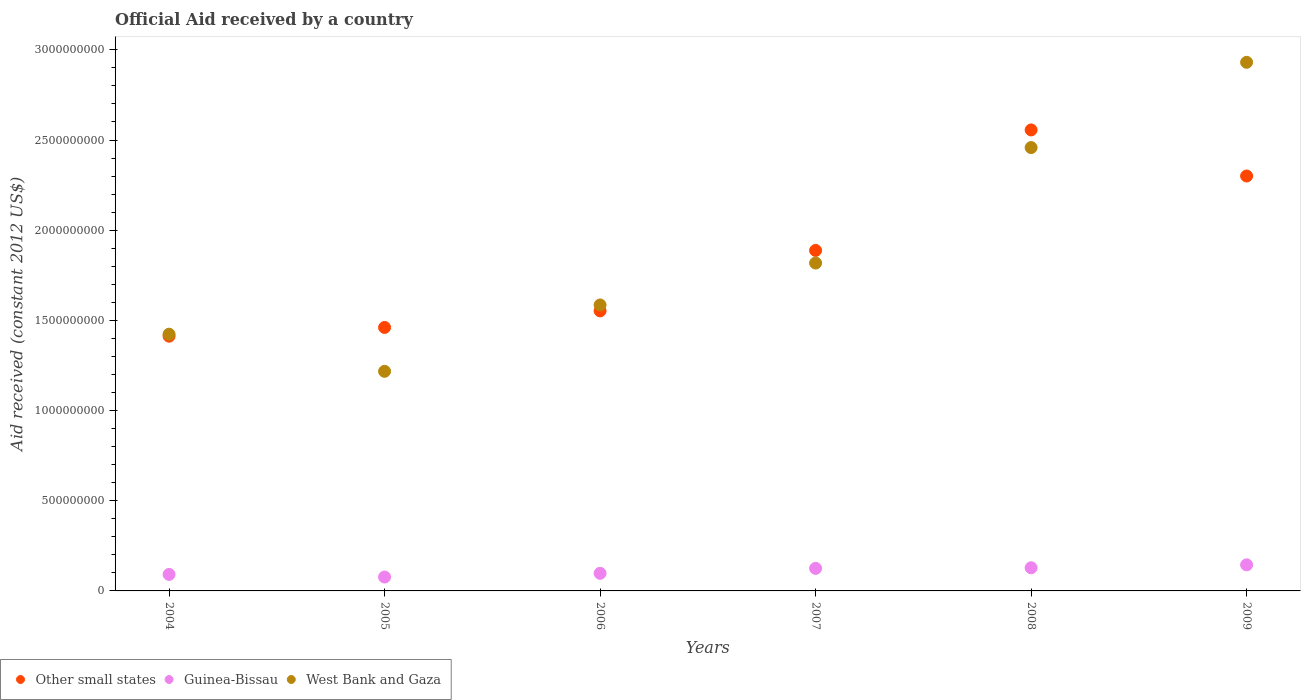How many different coloured dotlines are there?
Your answer should be very brief. 3. Is the number of dotlines equal to the number of legend labels?
Your answer should be very brief. Yes. What is the net official aid received in Guinea-Bissau in 2005?
Your answer should be compact. 7.70e+07. Across all years, what is the maximum net official aid received in West Bank and Gaza?
Your answer should be very brief. 2.93e+09. Across all years, what is the minimum net official aid received in Guinea-Bissau?
Offer a very short reply. 7.70e+07. What is the total net official aid received in Guinea-Bissau in the graph?
Make the answer very short. 6.64e+08. What is the difference between the net official aid received in Guinea-Bissau in 2004 and that in 2006?
Offer a terse response. -6.04e+06. What is the difference between the net official aid received in Other small states in 2009 and the net official aid received in West Bank and Gaza in 2008?
Your answer should be compact. -1.58e+08. What is the average net official aid received in Guinea-Bissau per year?
Provide a succinct answer. 1.11e+08. In the year 2007, what is the difference between the net official aid received in West Bank and Gaza and net official aid received in Guinea-Bissau?
Offer a very short reply. 1.69e+09. What is the ratio of the net official aid received in Other small states in 2004 to that in 2005?
Make the answer very short. 0.97. Is the difference between the net official aid received in West Bank and Gaza in 2004 and 2008 greater than the difference between the net official aid received in Guinea-Bissau in 2004 and 2008?
Make the answer very short. No. What is the difference between the highest and the second highest net official aid received in Guinea-Bissau?
Give a very brief answer. 1.62e+07. What is the difference between the highest and the lowest net official aid received in West Bank and Gaza?
Your answer should be very brief. 1.71e+09. In how many years, is the net official aid received in Guinea-Bissau greater than the average net official aid received in Guinea-Bissau taken over all years?
Your response must be concise. 3. Is it the case that in every year, the sum of the net official aid received in Other small states and net official aid received in West Bank and Gaza  is greater than the net official aid received in Guinea-Bissau?
Offer a very short reply. Yes. Is the net official aid received in Guinea-Bissau strictly less than the net official aid received in West Bank and Gaza over the years?
Ensure brevity in your answer.  Yes. How many years are there in the graph?
Offer a very short reply. 6. Does the graph contain grids?
Your answer should be very brief. No. How are the legend labels stacked?
Make the answer very short. Horizontal. What is the title of the graph?
Your response must be concise. Official Aid received by a country. What is the label or title of the X-axis?
Keep it short and to the point. Years. What is the label or title of the Y-axis?
Offer a terse response. Aid received (constant 2012 US$). What is the Aid received (constant 2012 US$) of Other small states in 2004?
Keep it short and to the point. 1.41e+09. What is the Aid received (constant 2012 US$) of Guinea-Bissau in 2004?
Keep it short and to the point. 9.15e+07. What is the Aid received (constant 2012 US$) of West Bank and Gaza in 2004?
Keep it short and to the point. 1.42e+09. What is the Aid received (constant 2012 US$) in Other small states in 2005?
Give a very brief answer. 1.46e+09. What is the Aid received (constant 2012 US$) in Guinea-Bissau in 2005?
Offer a very short reply. 7.70e+07. What is the Aid received (constant 2012 US$) in West Bank and Gaza in 2005?
Offer a terse response. 1.22e+09. What is the Aid received (constant 2012 US$) of Other small states in 2006?
Provide a succinct answer. 1.55e+09. What is the Aid received (constant 2012 US$) in Guinea-Bissau in 2006?
Offer a very short reply. 9.75e+07. What is the Aid received (constant 2012 US$) of West Bank and Gaza in 2006?
Make the answer very short. 1.59e+09. What is the Aid received (constant 2012 US$) of Other small states in 2007?
Ensure brevity in your answer.  1.89e+09. What is the Aid received (constant 2012 US$) in Guinea-Bissau in 2007?
Offer a very short reply. 1.25e+08. What is the Aid received (constant 2012 US$) in West Bank and Gaza in 2007?
Your answer should be very brief. 1.82e+09. What is the Aid received (constant 2012 US$) in Other small states in 2008?
Give a very brief answer. 2.56e+09. What is the Aid received (constant 2012 US$) of Guinea-Bissau in 2008?
Make the answer very short. 1.28e+08. What is the Aid received (constant 2012 US$) of West Bank and Gaza in 2008?
Your response must be concise. 2.46e+09. What is the Aid received (constant 2012 US$) of Other small states in 2009?
Your answer should be very brief. 2.30e+09. What is the Aid received (constant 2012 US$) of Guinea-Bissau in 2009?
Your answer should be compact. 1.45e+08. What is the Aid received (constant 2012 US$) of West Bank and Gaza in 2009?
Your answer should be compact. 2.93e+09. Across all years, what is the maximum Aid received (constant 2012 US$) of Other small states?
Your answer should be very brief. 2.56e+09. Across all years, what is the maximum Aid received (constant 2012 US$) of Guinea-Bissau?
Provide a succinct answer. 1.45e+08. Across all years, what is the maximum Aid received (constant 2012 US$) of West Bank and Gaza?
Your response must be concise. 2.93e+09. Across all years, what is the minimum Aid received (constant 2012 US$) of Other small states?
Offer a very short reply. 1.41e+09. Across all years, what is the minimum Aid received (constant 2012 US$) in Guinea-Bissau?
Your answer should be very brief. 7.70e+07. Across all years, what is the minimum Aid received (constant 2012 US$) in West Bank and Gaza?
Your response must be concise. 1.22e+09. What is the total Aid received (constant 2012 US$) of Other small states in the graph?
Provide a succinct answer. 1.12e+1. What is the total Aid received (constant 2012 US$) of Guinea-Bissau in the graph?
Your answer should be compact. 6.64e+08. What is the total Aid received (constant 2012 US$) in West Bank and Gaza in the graph?
Your answer should be compact. 1.14e+1. What is the difference between the Aid received (constant 2012 US$) in Other small states in 2004 and that in 2005?
Provide a short and direct response. -4.84e+07. What is the difference between the Aid received (constant 2012 US$) of Guinea-Bissau in 2004 and that in 2005?
Make the answer very short. 1.45e+07. What is the difference between the Aid received (constant 2012 US$) in West Bank and Gaza in 2004 and that in 2005?
Provide a short and direct response. 2.06e+08. What is the difference between the Aid received (constant 2012 US$) in Other small states in 2004 and that in 2006?
Make the answer very short. -1.40e+08. What is the difference between the Aid received (constant 2012 US$) of Guinea-Bissau in 2004 and that in 2006?
Ensure brevity in your answer.  -6.04e+06. What is the difference between the Aid received (constant 2012 US$) in West Bank and Gaza in 2004 and that in 2006?
Offer a very short reply. -1.62e+08. What is the difference between the Aid received (constant 2012 US$) in Other small states in 2004 and that in 2007?
Offer a very short reply. -4.75e+08. What is the difference between the Aid received (constant 2012 US$) in Guinea-Bissau in 2004 and that in 2007?
Provide a short and direct response. -3.35e+07. What is the difference between the Aid received (constant 2012 US$) in West Bank and Gaza in 2004 and that in 2007?
Keep it short and to the point. -3.94e+08. What is the difference between the Aid received (constant 2012 US$) in Other small states in 2004 and that in 2008?
Make the answer very short. -1.14e+09. What is the difference between the Aid received (constant 2012 US$) in Guinea-Bissau in 2004 and that in 2008?
Ensure brevity in your answer.  -3.69e+07. What is the difference between the Aid received (constant 2012 US$) in West Bank and Gaza in 2004 and that in 2008?
Make the answer very short. -1.03e+09. What is the difference between the Aid received (constant 2012 US$) in Other small states in 2004 and that in 2009?
Keep it short and to the point. -8.88e+08. What is the difference between the Aid received (constant 2012 US$) in Guinea-Bissau in 2004 and that in 2009?
Provide a succinct answer. -5.32e+07. What is the difference between the Aid received (constant 2012 US$) of West Bank and Gaza in 2004 and that in 2009?
Keep it short and to the point. -1.51e+09. What is the difference between the Aid received (constant 2012 US$) in Other small states in 2005 and that in 2006?
Your answer should be compact. -9.18e+07. What is the difference between the Aid received (constant 2012 US$) in Guinea-Bissau in 2005 and that in 2006?
Your answer should be very brief. -2.05e+07. What is the difference between the Aid received (constant 2012 US$) of West Bank and Gaza in 2005 and that in 2006?
Provide a short and direct response. -3.68e+08. What is the difference between the Aid received (constant 2012 US$) of Other small states in 2005 and that in 2007?
Offer a terse response. -4.27e+08. What is the difference between the Aid received (constant 2012 US$) of Guinea-Bissau in 2005 and that in 2007?
Your answer should be compact. -4.80e+07. What is the difference between the Aid received (constant 2012 US$) of West Bank and Gaza in 2005 and that in 2007?
Give a very brief answer. -6.00e+08. What is the difference between the Aid received (constant 2012 US$) in Other small states in 2005 and that in 2008?
Your answer should be compact. -1.10e+09. What is the difference between the Aid received (constant 2012 US$) of Guinea-Bissau in 2005 and that in 2008?
Ensure brevity in your answer.  -5.14e+07. What is the difference between the Aid received (constant 2012 US$) in West Bank and Gaza in 2005 and that in 2008?
Make the answer very short. -1.24e+09. What is the difference between the Aid received (constant 2012 US$) in Other small states in 2005 and that in 2009?
Your answer should be very brief. -8.40e+08. What is the difference between the Aid received (constant 2012 US$) in Guinea-Bissau in 2005 and that in 2009?
Your answer should be compact. -6.76e+07. What is the difference between the Aid received (constant 2012 US$) in West Bank and Gaza in 2005 and that in 2009?
Your response must be concise. -1.71e+09. What is the difference between the Aid received (constant 2012 US$) in Other small states in 2006 and that in 2007?
Your answer should be compact. -3.35e+08. What is the difference between the Aid received (constant 2012 US$) of Guinea-Bissau in 2006 and that in 2007?
Provide a short and direct response. -2.75e+07. What is the difference between the Aid received (constant 2012 US$) of West Bank and Gaza in 2006 and that in 2007?
Provide a succinct answer. -2.32e+08. What is the difference between the Aid received (constant 2012 US$) in Other small states in 2006 and that in 2008?
Ensure brevity in your answer.  -1.00e+09. What is the difference between the Aid received (constant 2012 US$) in Guinea-Bissau in 2006 and that in 2008?
Your response must be concise. -3.09e+07. What is the difference between the Aid received (constant 2012 US$) in West Bank and Gaza in 2006 and that in 2008?
Give a very brief answer. -8.73e+08. What is the difference between the Aid received (constant 2012 US$) in Other small states in 2006 and that in 2009?
Your answer should be very brief. -7.48e+08. What is the difference between the Aid received (constant 2012 US$) in Guinea-Bissau in 2006 and that in 2009?
Provide a succinct answer. -4.71e+07. What is the difference between the Aid received (constant 2012 US$) in West Bank and Gaza in 2006 and that in 2009?
Offer a very short reply. -1.35e+09. What is the difference between the Aid received (constant 2012 US$) in Other small states in 2007 and that in 2008?
Your response must be concise. -6.68e+08. What is the difference between the Aid received (constant 2012 US$) of Guinea-Bissau in 2007 and that in 2008?
Give a very brief answer. -3.38e+06. What is the difference between the Aid received (constant 2012 US$) in West Bank and Gaza in 2007 and that in 2008?
Your response must be concise. -6.40e+08. What is the difference between the Aid received (constant 2012 US$) of Other small states in 2007 and that in 2009?
Make the answer very short. -4.13e+08. What is the difference between the Aid received (constant 2012 US$) of Guinea-Bissau in 2007 and that in 2009?
Your response must be concise. -1.96e+07. What is the difference between the Aid received (constant 2012 US$) of West Bank and Gaza in 2007 and that in 2009?
Keep it short and to the point. -1.11e+09. What is the difference between the Aid received (constant 2012 US$) of Other small states in 2008 and that in 2009?
Provide a short and direct response. 2.55e+08. What is the difference between the Aid received (constant 2012 US$) in Guinea-Bissau in 2008 and that in 2009?
Ensure brevity in your answer.  -1.62e+07. What is the difference between the Aid received (constant 2012 US$) of West Bank and Gaza in 2008 and that in 2009?
Provide a short and direct response. -4.73e+08. What is the difference between the Aid received (constant 2012 US$) in Other small states in 2004 and the Aid received (constant 2012 US$) in Guinea-Bissau in 2005?
Keep it short and to the point. 1.34e+09. What is the difference between the Aid received (constant 2012 US$) in Other small states in 2004 and the Aid received (constant 2012 US$) in West Bank and Gaza in 2005?
Offer a very short reply. 1.95e+08. What is the difference between the Aid received (constant 2012 US$) in Guinea-Bissau in 2004 and the Aid received (constant 2012 US$) in West Bank and Gaza in 2005?
Your response must be concise. -1.13e+09. What is the difference between the Aid received (constant 2012 US$) of Other small states in 2004 and the Aid received (constant 2012 US$) of Guinea-Bissau in 2006?
Offer a very short reply. 1.31e+09. What is the difference between the Aid received (constant 2012 US$) of Other small states in 2004 and the Aid received (constant 2012 US$) of West Bank and Gaza in 2006?
Your response must be concise. -1.73e+08. What is the difference between the Aid received (constant 2012 US$) of Guinea-Bissau in 2004 and the Aid received (constant 2012 US$) of West Bank and Gaza in 2006?
Offer a very short reply. -1.49e+09. What is the difference between the Aid received (constant 2012 US$) of Other small states in 2004 and the Aid received (constant 2012 US$) of Guinea-Bissau in 2007?
Give a very brief answer. 1.29e+09. What is the difference between the Aid received (constant 2012 US$) in Other small states in 2004 and the Aid received (constant 2012 US$) in West Bank and Gaza in 2007?
Your response must be concise. -4.06e+08. What is the difference between the Aid received (constant 2012 US$) in Guinea-Bissau in 2004 and the Aid received (constant 2012 US$) in West Bank and Gaza in 2007?
Give a very brief answer. -1.73e+09. What is the difference between the Aid received (constant 2012 US$) of Other small states in 2004 and the Aid received (constant 2012 US$) of Guinea-Bissau in 2008?
Keep it short and to the point. 1.28e+09. What is the difference between the Aid received (constant 2012 US$) of Other small states in 2004 and the Aid received (constant 2012 US$) of West Bank and Gaza in 2008?
Offer a very short reply. -1.05e+09. What is the difference between the Aid received (constant 2012 US$) in Guinea-Bissau in 2004 and the Aid received (constant 2012 US$) in West Bank and Gaza in 2008?
Offer a very short reply. -2.37e+09. What is the difference between the Aid received (constant 2012 US$) in Other small states in 2004 and the Aid received (constant 2012 US$) in Guinea-Bissau in 2009?
Your answer should be compact. 1.27e+09. What is the difference between the Aid received (constant 2012 US$) in Other small states in 2004 and the Aid received (constant 2012 US$) in West Bank and Gaza in 2009?
Your answer should be compact. -1.52e+09. What is the difference between the Aid received (constant 2012 US$) of Guinea-Bissau in 2004 and the Aid received (constant 2012 US$) of West Bank and Gaza in 2009?
Your answer should be very brief. -2.84e+09. What is the difference between the Aid received (constant 2012 US$) in Other small states in 2005 and the Aid received (constant 2012 US$) in Guinea-Bissau in 2006?
Keep it short and to the point. 1.36e+09. What is the difference between the Aid received (constant 2012 US$) in Other small states in 2005 and the Aid received (constant 2012 US$) in West Bank and Gaza in 2006?
Your answer should be compact. -1.25e+08. What is the difference between the Aid received (constant 2012 US$) of Guinea-Bissau in 2005 and the Aid received (constant 2012 US$) of West Bank and Gaza in 2006?
Keep it short and to the point. -1.51e+09. What is the difference between the Aid received (constant 2012 US$) in Other small states in 2005 and the Aid received (constant 2012 US$) in Guinea-Bissau in 2007?
Give a very brief answer. 1.34e+09. What is the difference between the Aid received (constant 2012 US$) in Other small states in 2005 and the Aid received (constant 2012 US$) in West Bank and Gaza in 2007?
Give a very brief answer. -3.57e+08. What is the difference between the Aid received (constant 2012 US$) of Guinea-Bissau in 2005 and the Aid received (constant 2012 US$) of West Bank and Gaza in 2007?
Offer a terse response. -1.74e+09. What is the difference between the Aid received (constant 2012 US$) of Other small states in 2005 and the Aid received (constant 2012 US$) of Guinea-Bissau in 2008?
Your response must be concise. 1.33e+09. What is the difference between the Aid received (constant 2012 US$) in Other small states in 2005 and the Aid received (constant 2012 US$) in West Bank and Gaza in 2008?
Make the answer very short. -9.97e+08. What is the difference between the Aid received (constant 2012 US$) in Guinea-Bissau in 2005 and the Aid received (constant 2012 US$) in West Bank and Gaza in 2008?
Give a very brief answer. -2.38e+09. What is the difference between the Aid received (constant 2012 US$) of Other small states in 2005 and the Aid received (constant 2012 US$) of Guinea-Bissau in 2009?
Keep it short and to the point. 1.32e+09. What is the difference between the Aid received (constant 2012 US$) in Other small states in 2005 and the Aid received (constant 2012 US$) in West Bank and Gaza in 2009?
Offer a very short reply. -1.47e+09. What is the difference between the Aid received (constant 2012 US$) of Guinea-Bissau in 2005 and the Aid received (constant 2012 US$) of West Bank and Gaza in 2009?
Your answer should be very brief. -2.85e+09. What is the difference between the Aid received (constant 2012 US$) of Other small states in 2006 and the Aid received (constant 2012 US$) of Guinea-Bissau in 2007?
Your answer should be very brief. 1.43e+09. What is the difference between the Aid received (constant 2012 US$) of Other small states in 2006 and the Aid received (constant 2012 US$) of West Bank and Gaza in 2007?
Your response must be concise. -2.65e+08. What is the difference between the Aid received (constant 2012 US$) in Guinea-Bissau in 2006 and the Aid received (constant 2012 US$) in West Bank and Gaza in 2007?
Ensure brevity in your answer.  -1.72e+09. What is the difference between the Aid received (constant 2012 US$) in Other small states in 2006 and the Aid received (constant 2012 US$) in Guinea-Bissau in 2008?
Your answer should be compact. 1.42e+09. What is the difference between the Aid received (constant 2012 US$) of Other small states in 2006 and the Aid received (constant 2012 US$) of West Bank and Gaza in 2008?
Your response must be concise. -9.06e+08. What is the difference between the Aid received (constant 2012 US$) in Guinea-Bissau in 2006 and the Aid received (constant 2012 US$) in West Bank and Gaza in 2008?
Give a very brief answer. -2.36e+09. What is the difference between the Aid received (constant 2012 US$) in Other small states in 2006 and the Aid received (constant 2012 US$) in Guinea-Bissau in 2009?
Provide a succinct answer. 1.41e+09. What is the difference between the Aid received (constant 2012 US$) of Other small states in 2006 and the Aid received (constant 2012 US$) of West Bank and Gaza in 2009?
Make the answer very short. -1.38e+09. What is the difference between the Aid received (constant 2012 US$) in Guinea-Bissau in 2006 and the Aid received (constant 2012 US$) in West Bank and Gaza in 2009?
Your answer should be compact. -2.83e+09. What is the difference between the Aid received (constant 2012 US$) in Other small states in 2007 and the Aid received (constant 2012 US$) in Guinea-Bissau in 2008?
Your response must be concise. 1.76e+09. What is the difference between the Aid received (constant 2012 US$) of Other small states in 2007 and the Aid received (constant 2012 US$) of West Bank and Gaza in 2008?
Keep it short and to the point. -5.70e+08. What is the difference between the Aid received (constant 2012 US$) of Guinea-Bissau in 2007 and the Aid received (constant 2012 US$) of West Bank and Gaza in 2008?
Offer a terse response. -2.33e+09. What is the difference between the Aid received (constant 2012 US$) of Other small states in 2007 and the Aid received (constant 2012 US$) of Guinea-Bissau in 2009?
Offer a very short reply. 1.74e+09. What is the difference between the Aid received (constant 2012 US$) in Other small states in 2007 and the Aid received (constant 2012 US$) in West Bank and Gaza in 2009?
Provide a succinct answer. -1.04e+09. What is the difference between the Aid received (constant 2012 US$) of Guinea-Bissau in 2007 and the Aid received (constant 2012 US$) of West Bank and Gaza in 2009?
Make the answer very short. -2.81e+09. What is the difference between the Aid received (constant 2012 US$) in Other small states in 2008 and the Aid received (constant 2012 US$) in Guinea-Bissau in 2009?
Your answer should be very brief. 2.41e+09. What is the difference between the Aid received (constant 2012 US$) in Other small states in 2008 and the Aid received (constant 2012 US$) in West Bank and Gaza in 2009?
Your answer should be very brief. -3.75e+08. What is the difference between the Aid received (constant 2012 US$) of Guinea-Bissau in 2008 and the Aid received (constant 2012 US$) of West Bank and Gaza in 2009?
Your answer should be compact. -2.80e+09. What is the average Aid received (constant 2012 US$) of Other small states per year?
Your answer should be compact. 1.86e+09. What is the average Aid received (constant 2012 US$) in Guinea-Bissau per year?
Make the answer very short. 1.11e+08. What is the average Aid received (constant 2012 US$) of West Bank and Gaza per year?
Offer a terse response. 1.91e+09. In the year 2004, what is the difference between the Aid received (constant 2012 US$) of Other small states and Aid received (constant 2012 US$) of Guinea-Bissau?
Offer a terse response. 1.32e+09. In the year 2004, what is the difference between the Aid received (constant 2012 US$) of Other small states and Aid received (constant 2012 US$) of West Bank and Gaza?
Your response must be concise. -1.11e+07. In the year 2004, what is the difference between the Aid received (constant 2012 US$) of Guinea-Bissau and Aid received (constant 2012 US$) of West Bank and Gaza?
Make the answer very short. -1.33e+09. In the year 2005, what is the difference between the Aid received (constant 2012 US$) in Other small states and Aid received (constant 2012 US$) in Guinea-Bissau?
Ensure brevity in your answer.  1.38e+09. In the year 2005, what is the difference between the Aid received (constant 2012 US$) in Other small states and Aid received (constant 2012 US$) in West Bank and Gaza?
Make the answer very short. 2.43e+08. In the year 2005, what is the difference between the Aid received (constant 2012 US$) of Guinea-Bissau and Aid received (constant 2012 US$) of West Bank and Gaza?
Provide a succinct answer. -1.14e+09. In the year 2006, what is the difference between the Aid received (constant 2012 US$) of Other small states and Aid received (constant 2012 US$) of Guinea-Bissau?
Keep it short and to the point. 1.46e+09. In the year 2006, what is the difference between the Aid received (constant 2012 US$) of Other small states and Aid received (constant 2012 US$) of West Bank and Gaza?
Give a very brief answer. -3.30e+07. In the year 2006, what is the difference between the Aid received (constant 2012 US$) in Guinea-Bissau and Aid received (constant 2012 US$) in West Bank and Gaza?
Provide a short and direct response. -1.49e+09. In the year 2007, what is the difference between the Aid received (constant 2012 US$) of Other small states and Aid received (constant 2012 US$) of Guinea-Bissau?
Provide a succinct answer. 1.76e+09. In the year 2007, what is the difference between the Aid received (constant 2012 US$) in Other small states and Aid received (constant 2012 US$) in West Bank and Gaza?
Keep it short and to the point. 6.99e+07. In the year 2007, what is the difference between the Aid received (constant 2012 US$) in Guinea-Bissau and Aid received (constant 2012 US$) in West Bank and Gaza?
Give a very brief answer. -1.69e+09. In the year 2008, what is the difference between the Aid received (constant 2012 US$) of Other small states and Aid received (constant 2012 US$) of Guinea-Bissau?
Provide a succinct answer. 2.43e+09. In the year 2008, what is the difference between the Aid received (constant 2012 US$) in Other small states and Aid received (constant 2012 US$) in West Bank and Gaza?
Give a very brief answer. 9.78e+07. In the year 2008, what is the difference between the Aid received (constant 2012 US$) of Guinea-Bissau and Aid received (constant 2012 US$) of West Bank and Gaza?
Keep it short and to the point. -2.33e+09. In the year 2009, what is the difference between the Aid received (constant 2012 US$) in Other small states and Aid received (constant 2012 US$) in Guinea-Bissau?
Provide a succinct answer. 2.16e+09. In the year 2009, what is the difference between the Aid received (constant 2012 US$) in Other small states and Aid received (constant 2012 US$) in West Bank and Gaza?
Keep it short and to the point. -6.30e+08. In the year 2009, what is the difference between the Aid received (constant 2012 US$) of Guinea-Bissau and Aid received (constant 2012 US$) of West Bank and Gaza?
Your answer should be compact. -2.79e+09. What is the ratio of the Aid received (constant 2012 US$) of Other small states in 2004 to that in 2005?
Your answer should be compact. 0.97. What is the ratio of the Aid received (constant 2012 US$) of Guinea-Bissau in 2004 to that in 2005?
Your answer should be compact. 1.19. What is the ratio of the Aid received (constant 2012 US$) of West Bank and Gaza in 2004 to that in 2005?
Ensure brevity in your answer.  1.17. What is the ratio of the Aid received (constant 2012 US$) of Other small states in 2004 to that in 2006?
Ensure brevity in your answer.  0.91. What is the ratio of the Aid received (constant 2012 US$) of Guinea-Bissau in 2004 to that in 2006?
Make the answer very short. 0.94. What is the ratio of the Aid received (constant 2012 US$) of West Bank and Gaza in 2004 to that in 2006?
Your response must be concise. 0.9. What is the ratio of the Aid received (constant 2012 US$) of Other small states in 2004 to that in 2007?
Provide a succinct answer. 0.75. What is the ratio of the Aid received (constant 2012 US$) of Guinea-Bissau in 2004 to that in 2007?
Your answer should be compact. 0.73. What is the ratio of the Aid received (constant 2012 US$) in West Bank and Gaza in 2004 to that in 2007?
Offer a very short reply. 0.78. What is the ratio of the Aid received (constant 2012 US$) in Other small states in 2004 to that in 2008?
Your response must be concise. 0.55. What is the ratio of the Aid received (constant 2012 US$) in Guinea-Bissau in 2004 to that in 2008?
Your answer should be compact. 0.71. What is the ratio of the Aid received (constant 2012 US$) of West Bank and Gaza in 2004 to that in 2008?
Give a very brief answer. 0.58. What is the ratio of the Aid received (constant 2012 US$) of Other small states in 2004 to that in 2009?
Your answer should be compact. 0.61. What is the ratio of the Aid received (constant 2012 US$) in Guinea-Bissau in 2004 to that in 2009?
Give a very brief answer. 0.63. What is the ratio of the Aid received (constant 2012 US$) of West Bank and Gaza in 2004 to that in 2009?
Make the answer very short. 0.49. What is the ratio of the Aid received (constant 2012 US$) in Other small states in 2005 to that in 2006?
Your response must be concise. 0.94. What is the ratio of the Aid received (constant 2012 US$) of Guinea-Bissau in 2005 to that in 2006?
Your answer should be compact. 0.79. What is the ratio of the Aid received (constant 2012 US$) of West Bank and Gaza in 2005 to that in 2006?
Give a very brief answer. 0.77. What is the ratio of the Aid received (constant 2012 US$) of Other small states in 2005 to that in 2007?
Your answer should be very brief. 0.77. What is the ratio of the Aid received (constant 2012 US$) in Guinea-Bissau in 2005 to that in 2007?
Ensure brevity in your answer.  0.62. What is the ratio of the Aid received (constant 2012 US$) of West Bank and Gaza in 2005 to that in 2007?
Give a very brief answer. 0.67. What is the ratio of the Aid received (constant 2012 US$) of Other small states in 2005 to that in 2008?
Your answer should be compact. 0.57. What is the ratio of the Aid received (constant 2012 US$) of Guinea-Bissau in 2005 to that in 2008?
Ensure brevity in your answer.  0.6. What is the ratio of the Aid received (constant 2012 US$) of West Bank and Gaza in 2005 to that in 2008?
Provide a succinct answer. 0.5. What is the ratio of the Aid received (constant 2012 US$) of Other small states in 2005 to that in 2009?
Your answer should be very brief. 0.64. What is the ratio of the Aid received (constant 2012 US$) in Guinea-Bissau in 2005 to that in 2009?
Give a very brief answer. 0.53. What is the ratio of the Aid received (constant 2012 US$) in West Bank and Gaza in 2005 to that in 2009?
Give a very brief answer. 0.42. What is the ratio of the Aid received (constant 2012 US$) of Other small states in 2006 to that in 2007?
Ensure brevity in your answer.  0.82. What is the ratio of the Aid received (constant 2012 US$) of Guinea-Bissau in 2006 to that in 2007?
Give a very brief answer. 0.78. What is the ratio of the Aid received (constant 2012 US$) of West Bank and Gaza in 2006 to that in 2007?
Make the answer very short. 0.87. What is the ratio of the Aid received (constant 2012 US$) in Other small states in 2006 to that in 2008?
Your response must be concise. 0.61. What is the ratio of the Aid received (constant 2012 US$) in Guinea-Bissau in 2006 to that in 2008?
Your response must be concise. 0.76. What is the ratio of the Aid received (constant 2012 US$) in West Bank and Gaza in 2006 to that in 2008?
Your answer should be compact. 0.65. What is the ratio of the Aid received (constant 2012 US$) in Other small states in 2006 to that in 2009?
Your response must be concise. 0.67. What is the ratio of the Aid received (constant 2012 US$) of Guinea-Bissau in 2006 to that in 2009?
Your answer should be compact. 0.67. What is the ratio of the Aid received (constant 2012 US$) of West Bank and Gaza in 2006 to that in 2009?
Provide a succinct answer. 0.54. What is the ratio of the Aid received (constant 2012 US$) in Other small states in 2007 to that in 2008?
Keep it short and to the point. 0.74. What is the ratio of the Aid received (constant 2012 US$) of Guinea-Bissau in 2007 to that in 2008?
Offer a terse response. 0.97. What is the ratio of the Aid received (constant 2012 US$) of West Bank and Gaza in 2007 to that in 2008?
Your answer should be compact. 0.74. What is the ratio of the Aid received (constant 2012 US$) in Other small states in 2007 to that in 2009?
Ensure brevity in your answer.  0.82. What is the ratio of the Aid received (constant 2012 US$) of Guinea-Bissau in 2007 to that in 2009?
Offer a very short reply. 0.86. What is the ratio of the Aid received (constant 2012 US$) in West Bank and Gaza in 2007 to that in 2009?
Offer a very short reply. 0.62. What is the ratio of the Aid received (constant 2012 US$) of Other small states in 2008 to that in 2009?
Your answer should be very brief. 1.11. What is the ratio of the Aid received (constant 2012 US$) of Guinea-Bissau in 2008 to that in 2009?
Your answer should be compact. 0.89. What is the ratio of the Aid received (constant 2012 US$) of West Bank and Gaza in 2008 to that in 2009?
Offer a very short reply. 0.84. What is the difference between the highest and the second highest Aid received (constant 2012 US$) of Other small states?
Your response must be concise. 2.55e+08. What is the difference between the highest and the second highest Aid received (constant 2012 US$) of Guinea-Bissau?
Give a very brief answer. 1.62e+07. What is the difference between the highest and the second highest Aid received (constant 2012 US$) of West Bank and Gaza?
Offer a very short reply. 4.73e+08. What is the difference between the highest and the lowest Aid received (constant 2012 US$) in Other small states?
Offer a very short reply. 1.14e+09. What is the difference between the highest and the lowest Aid received (constant 2012 US$) of Guinea-Bissau?
Offer a very short reply. 6.76e+07. What is the difference between the highest and the lowest Aid received (constant 2012 US$) of West Bank and Gaza?
Ensure brevity in your answer.  1.71e+09. 